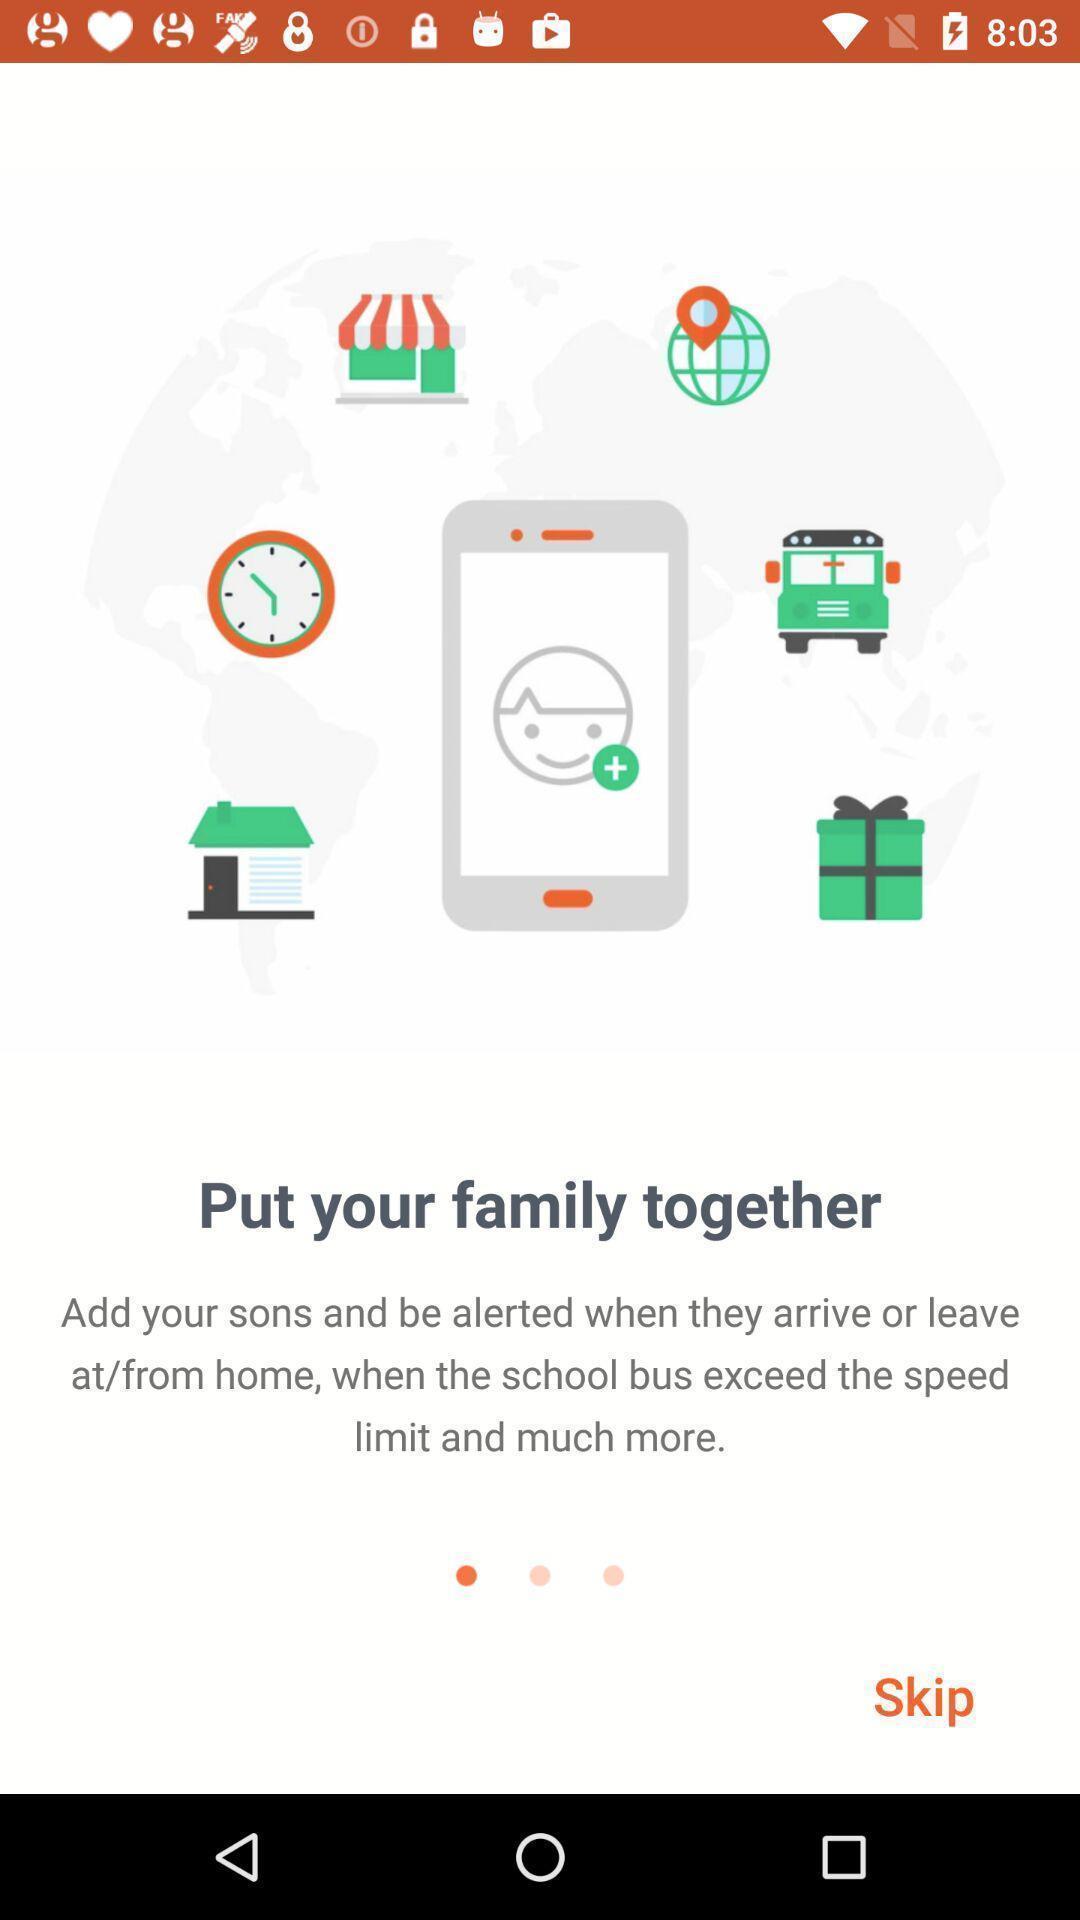Describe this image in words. Welcome page. 